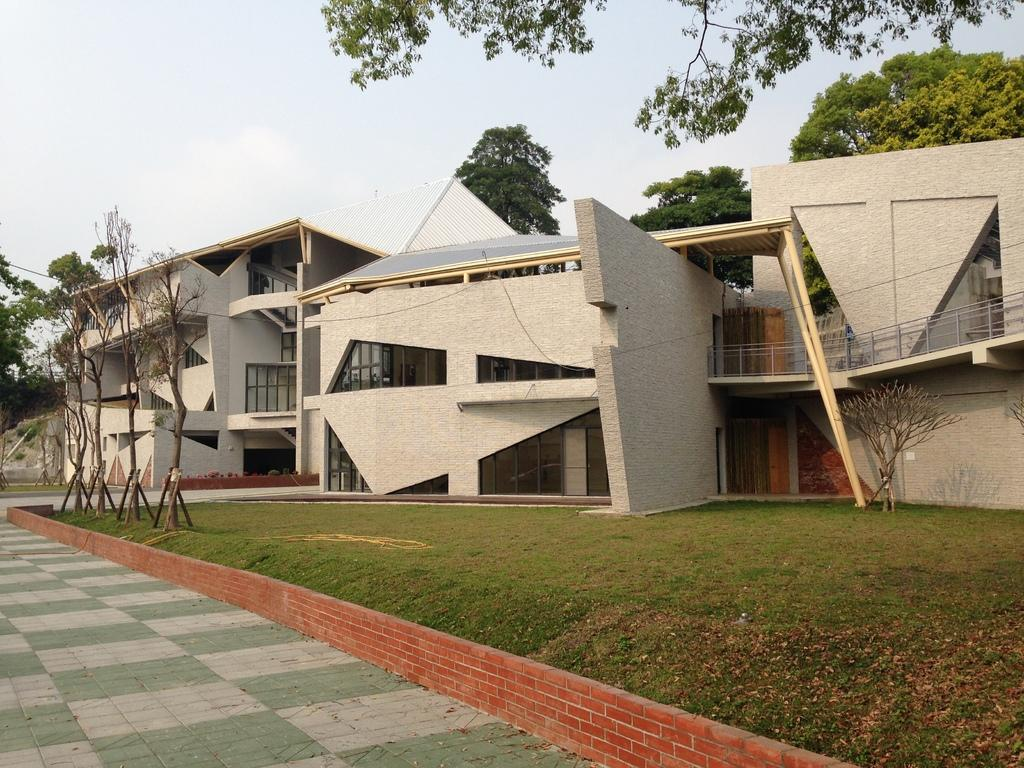What type of vegetation is present in the image? There is grass in the image. What structures can be seen in the background of the image? There are houses in the background of the image. What other natural elements are visible in the background of the image? There are trees in the background of the image. What is visible in the sky in the background of the image? There are clouds in the sky in the background of the image. What team is represented by the grass in the image? The grass in the image does not represent any team; it is simply a natural element in the scene. 